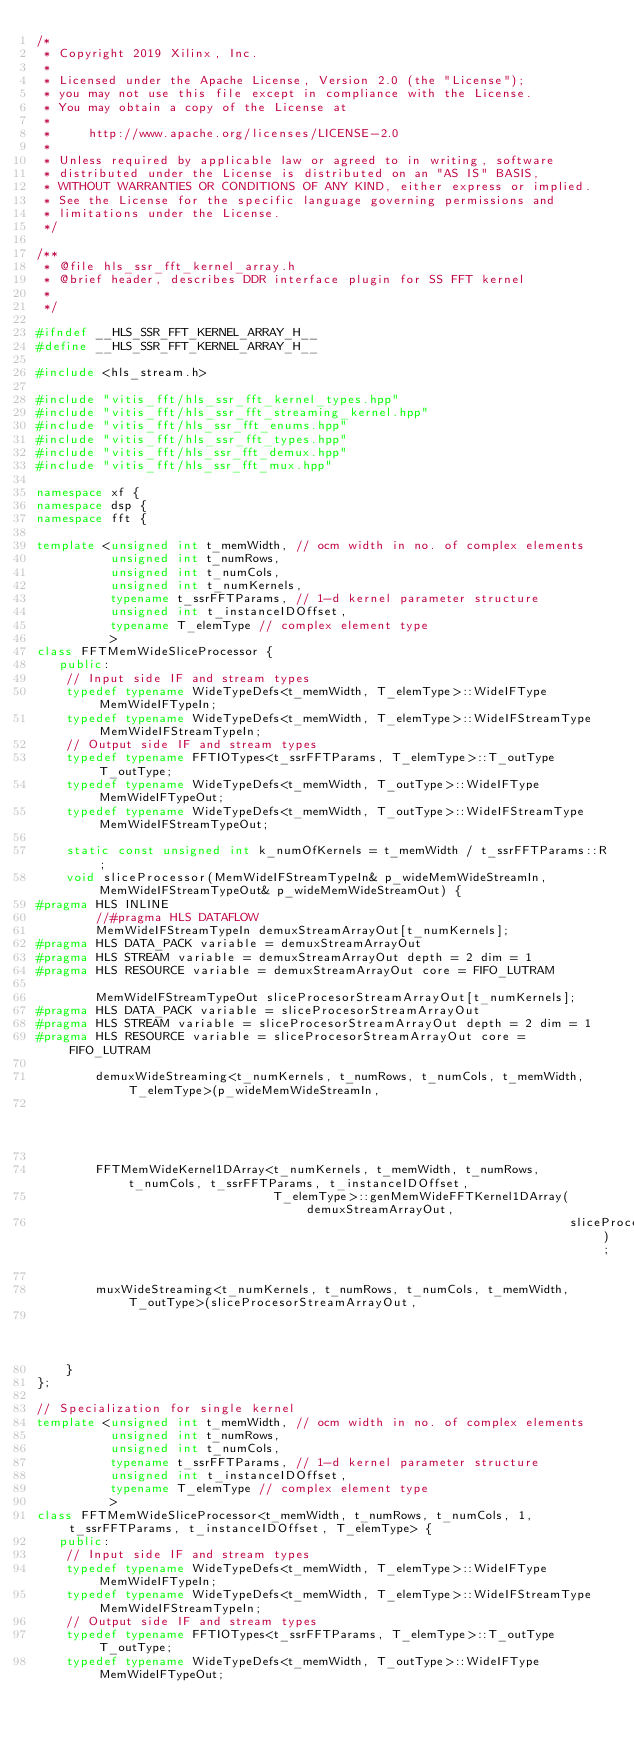<code> <loc_0><loc_0><loc_500><loc_500><_C++_>/*
 * Copyright 2019 Xilinx, Inc.
 *
 * Licensed under the Apache License, Version 2.0 (the "License");
 * you may not use this file except in compliance with the License.
 * You may obtain a copy of the License at
 *
 *     http://www.apache.org/licenses/LICENSE-2.0
 *
 * Unless required by applicable law or agreed to in writing, software
 * distributed under the License is distributed on an "AS IS" BASIS,
 * WITHOUT WARRANTIES OR CONDITIONS OF ANY KIND, either express or implied.
 * See the License for the specific language governing permissions and
 * limitations under the License.
 */

/**
 * @file hls_ssr_fft_kernel_array.h
 * @brief header, describes DDR interface plugin for SS FFT kernel
 *
 */

#ifndef __HLS_SSR_FFT_KERNEL_ARRAY_H__
#define __HLS_SSR_FFT_KERNEL_ARRAY_H__

#include <hls_stream.h>

#include "vitis_fft/hls_ssr_fft_kernel_types.hpp"
#include "vitis_fft/hls_ssr_fft_streaming_kernel.hpp"
#include "vitis_fft/hls_ssr_fft_enums.hpp"
#include "vitis_fft/hls_ssr_fft_types.hpp"
#include "vitis_fft/hls_ssr_fft_demux.hpp"
#include "vitis_fft/hls_ssr_fft_mux.hpp"

namespace xf {
namespace dsp {
namespace fft {

template <unsigned int t_memWidth, // ocm width in no. of complex elements
          unsigned int t_numRows,
          unsigned int t_numCols,
          unsigned int t_numKernels,
          typename t_ssrFFTParams, // 1-d kernel parameter structure
          unsigned int t_instanceIDOffset,
          typename T_elemType // complex element type
          >
class FFTMemWideSliceProcessor {
   public:
    // Input side IF and stream types
    typedef typename WideTypeDefs<t_memWidth, T_elemType>::WideIFType MemWideIFTypeIn;
    typedef typename WideTypeDefs<t_memWidth, T_elemType>::WideIFStreamType MemWideIFStreamTypeIn;
    // Output side IF and stream types
    typedef typename FFTIOTypes<t_ssrFFTParams, T_elemType>::T_outType T_outType;
    typedef typename WideTypeDefs<t_memWidth, T_outType>::WideIFType MemWideIFTypeOut;
    typedef typename WideTypeDefs<t_memWidth, T_outType>::WideIFStreamType MemWideIFStreamTypeOut;

    static const unsigned int k_numOfKernels = t_memWidth / t_ssrFFTParams::R;
    void sliceProcessor(MemWideIFStreamTypeIn& p_wideMemWideStreamIn, MemWideIFStreamTypeOut& p_wideMemWideStreamOut) {
#pragma HLS INLINE
        //#pragma HLS DATAFLOW
        MemWideIFStreamTypeIn demuxStreamArrayOut[t_numKernels];
#pragma HLS DATA_PACK variable = demuxStreamArrayOut
#pragma HLS STREAM variable = demuxStreamArrayOut depth = 2 dim = 1
#pragma HLS RESOURCE variable = demuxStreamArrayOut core = FIFO_LUTRAM

        MemWideIFStreamTypeOut sliceProcesorStreamArrayOut[t_numKernels];
#pragma HLS DATA_PACK variable = sliceProcesorStreamArrayOut
#pragma HLS STREAM variable = sliceProcesorStreamArrayOut depth = 2 dim = 1
#pragma HLS RESOURCE variable = sliceProcesorStreamArrayOut core = FIFO_LUTRAM

        demuxWideStreaming<t_numKernels, t_numRows, t_numCols, t_memWidth, T_elemType>(p_wideMemWideStreamIn,
                                                                                       demuxStreamArrayOut);

        FFTMemWideKernel1DArray<t_numKernels, t_memWidth, t_numRows, t_numCols, t_ssrFFTParams, t_instanceIDOffset,
                                T_elemType>::genMemWideFFTKernel1DArray(demuxStreamArrayOut,
                                                                        sliceProcesorStreamArrayOut);

        muxWideStreaming<t_numKernels, t_numRows, t_numCols, t_memWidth, T_outType>(sliceProcesorStreamArrayOut,
                                                                                    p_wideMemWideStreamOut);
    }
};

// Specialization for single kernel
template <unsigned int t_memWidth, // ocm width in no. of complex elements
          unsigned int t_numRows,
          unsigned int t_numCols,
          typename t_ssrFFTParams, // 1-d kernel parameter structure
          unsigned int t_instanceIDOffset,
          typename T_elemType // complex element type
          >
class FFTMemWideSliceProcessor<t_memWidth, t_numRows, t_numCols, 1, t_ssrFFTParams, t_instanceIDOffset, T_elemType> {
   public:
    // Input side IF and stream types
    typedef typename WideTypeDefs<t_memWidth, T_elemType>::WideIFType MemWideIFTypeIn;
    typedef typename WideTypeDefs<t_memWidth, T_elemType>::WideIFStreamType MemWideIFStreamTypeIn;
    // Output side IF and stream types
    typedef typename FFTIOTypes<t_ssrFFTParams, T_elemType>::T_outType T_outType;
    typedef typename WideTypeDefs<t_memWidth, T_outType>::WideIFType MemWideIFTypeOut;</code> 